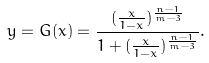Convert formula to latex. <formula><loc_0><loc_0><loc_500><loc_500>y = G ( x ) = \frac { ( \frac { x } { 1 - x } ) ^ { \frac { n - 1 } { m - 3 } } } { 1 + ( \frac { x } { 1 - x } ) ^ { \frac { n - 1 } { m - 3 } } } .</formula> 